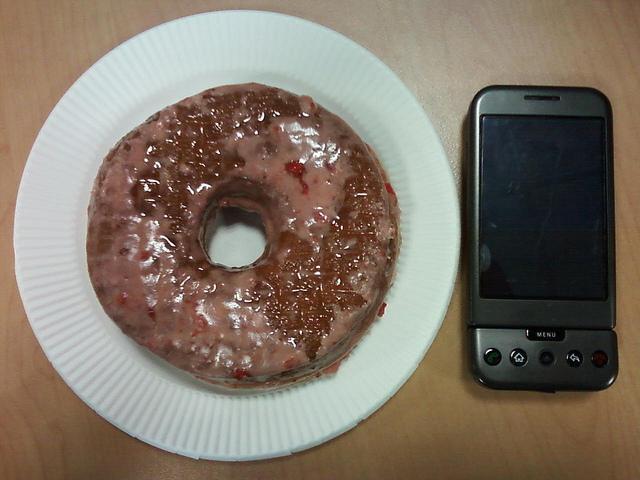How many buttons does the phone have?
Give a very brief answer. 5. How many train tracks are here?
Give a very brief answer. 0. 